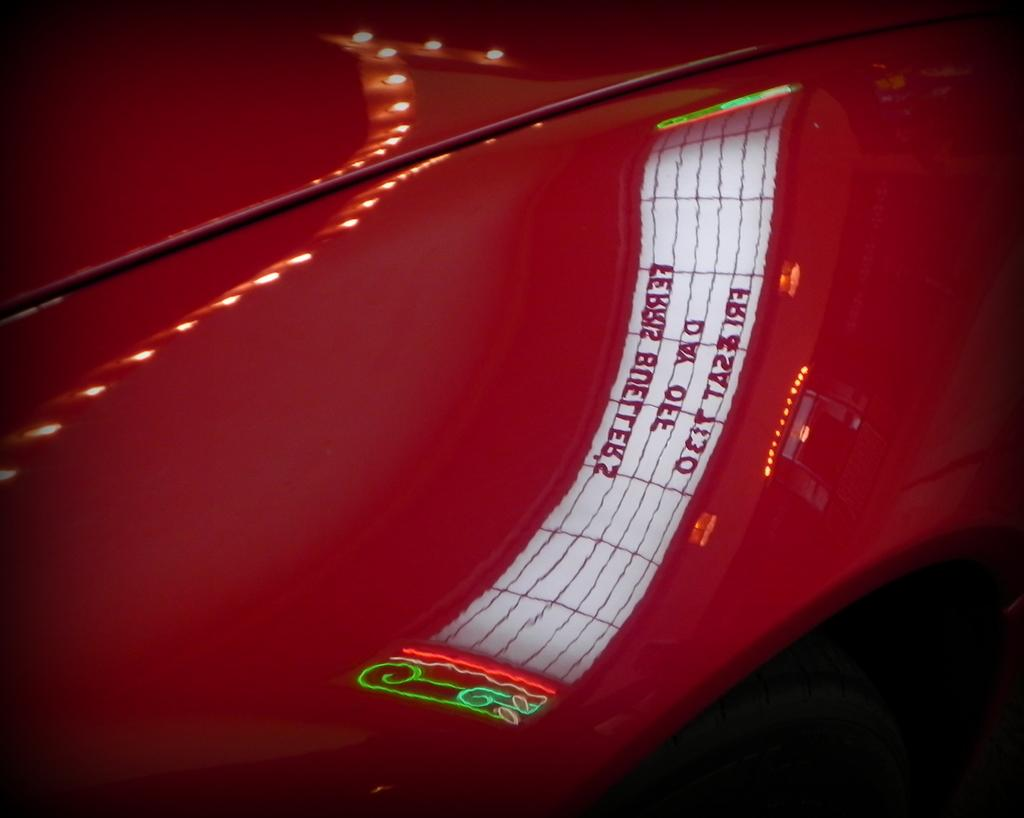What is the main subject of the image? The main subject of the image is a car. Can you describe the color of the car? The car is red in color. What else can be observed on the car in the image? There is a reflection of text on the car. What type of butter is being used to polish the car in the image? There is no butter present in the image, and the car is not being polished. 